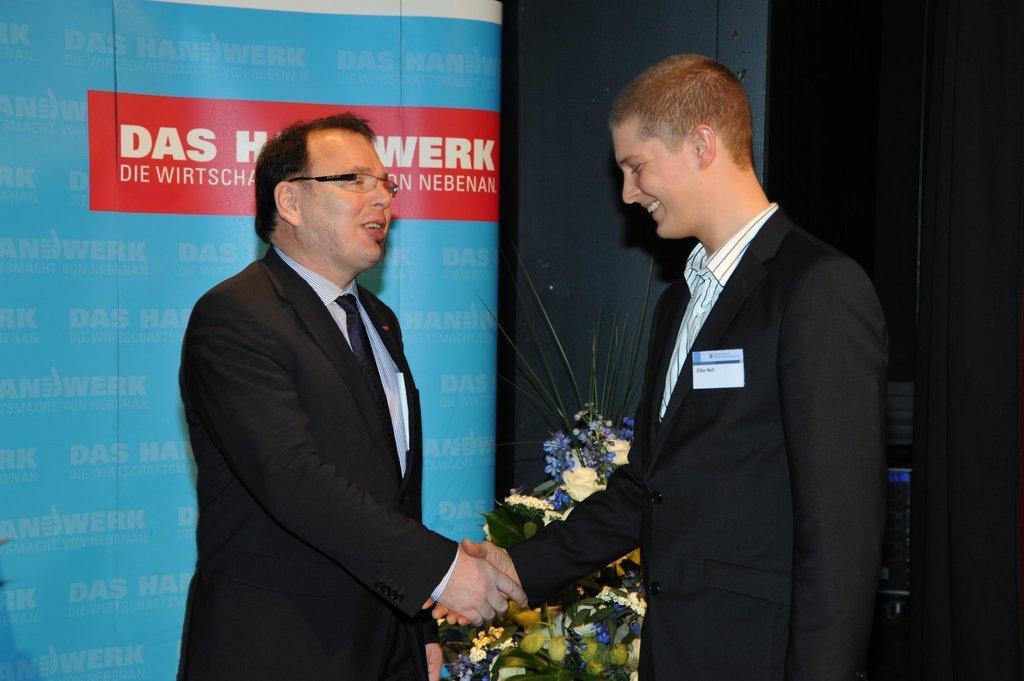Can you describe this image briefly? In the picture I can see a person wearing black color blazer, tie, shirt and spectacles is on the left side of the image and another person wearing blazer, shirt is smiling and they both are hand shaking. In the background, we can see the blue color banner on which we can see some edited text and here we can see the flower bouquet. The right side of the image is dark. 